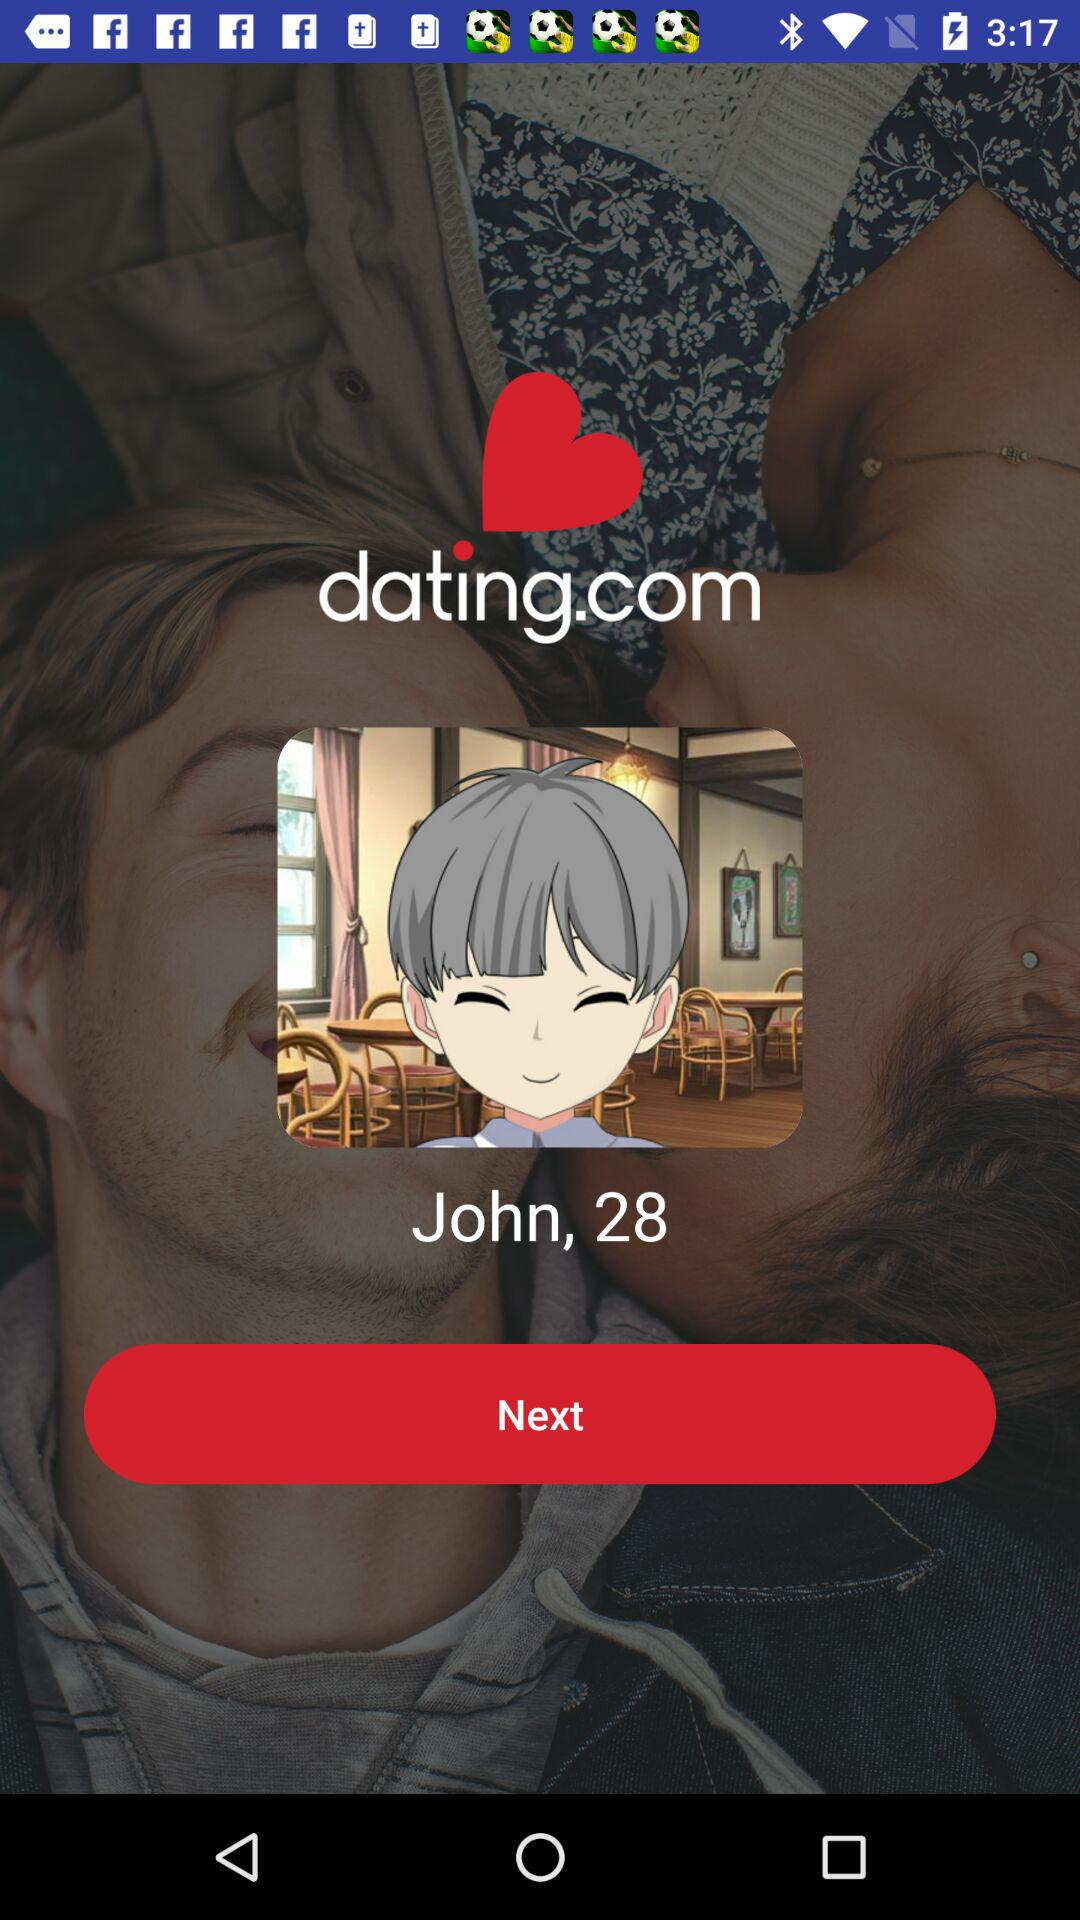What is the application name? The application name is "Dating.com™: Chat, Meet People". 